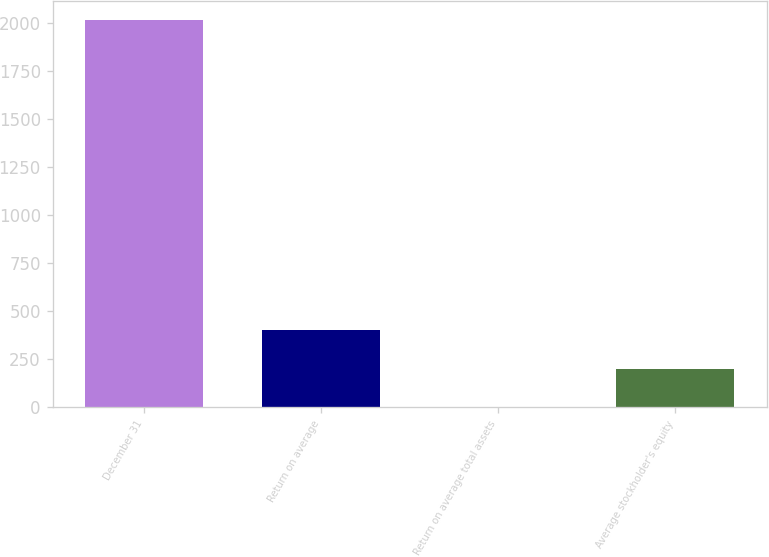<chart> <loc_0><loc_0><loc_500><loc_500><bar_chart><fcel>December 31<fcel>Return on average<fcel>Return on average total assets<fcel>Average stockholder's equity<nl><fcel>2014<fcel>403.53<fcel>0.91<fcel>202.22<nl></chart> 